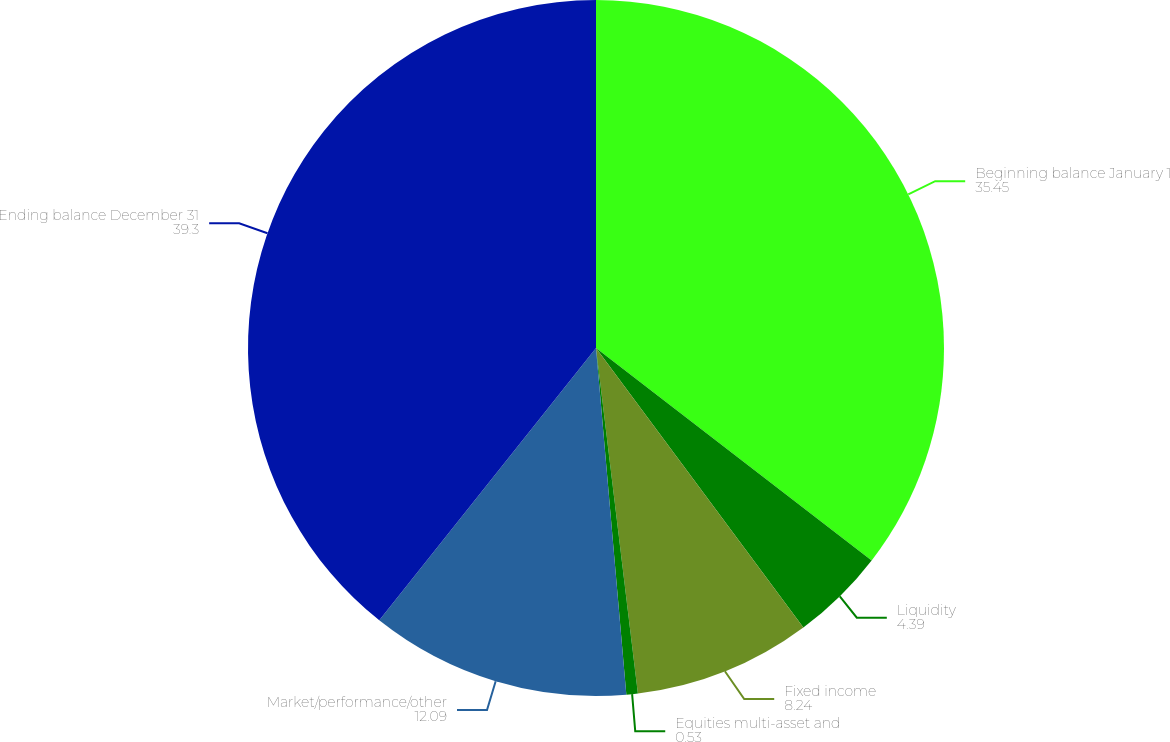<chart> <loc_0><loc_0><loc_500><loc_500><pie_chart><fcel>Beginning balance January 1<fcel>Liquidity<fcel>Fixed income<fcel>Equities multi-asset and<fcel>Market/performance/other<fcel>Ending balance December 31<nl><fcel>35.45%<fcel>4.39%<fcel>8.24%<fcel>0.53%<fcel>12.09%<fcel>39.3%<nl></chart> 